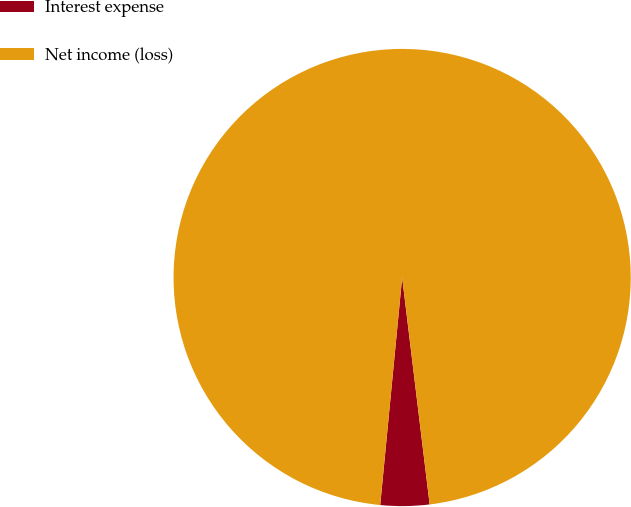Convert chart. <chart><loc_0><loc_0><loc_500><loc_500><pie_chart><fcel>Interest expense<fcel>Net income (loss)<nl><fcel>3.45%<fcel>96.55%<nl></chart> 